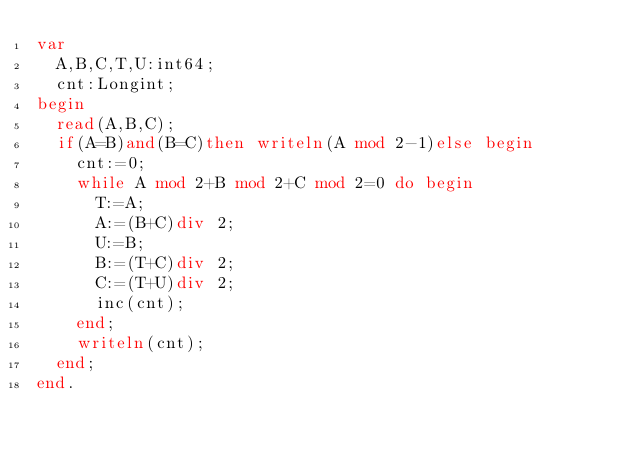<code> <loc_0><loc_0><loc_500><loc_500><_Pascal_>var
	A,B,C,T,U:int64;
	cnt:Longint;
begin
	read(A,B,C);
	if(A=B)and(B=C)then writeln(A mod 2-1)else begin
		cnt:=0;
		while A mod 2+B mod 2+C mod 2=0 do begin
			T:=A;
			A:=(B+C)div 2;
			U:=B;
			B:=(T+C)div 2;
			C:=(T+U)div 2;
			inc(cnt);
		end;
		writeln(cnt);
	end;
end.
</code> 